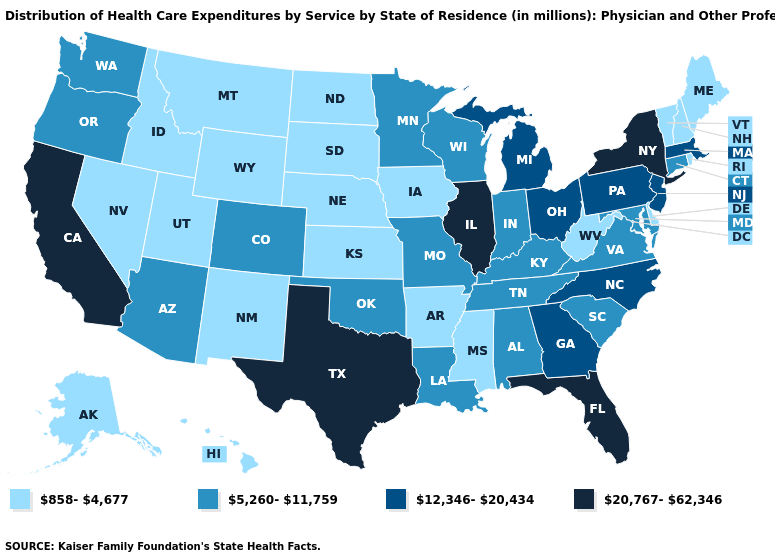How many symbols are there in the legend?
Concise answer only. 4. What is the highest value in the USA?
Give a very brief answer. 20,767-62,346. Name the states that have a value in the range 20,767-62,346?
Keep it brief. California, Florida, Illinois, New York, Texas. What is the lowest value in states that border California?
Write a very short answer. 858-4,677. Does Oregon have the same value as Rhode Island?
Give a very brief answer. No. What is the value of Massachusetts?
Give a very brief answer. 12,346-20,434. Name the states that have a value in the range 12,346-20,434?
Quick response, please. Georgia, Massachusetts, Michigan, New Jersey, North Carolina, Ohio, Pennsylvania. Name the states that have a value in the range 858-4,677?
Quick response, please. Alaska, Arkansas, Delaware, Hawaii, Idaho, Iowa, Kansas, Maine, Mississippi, Montana, Nebraska, Nevada, New Hampshire, New Mexico, North Dakota, Rhode Island, South Dakota, Utah, Vermont, West Virginia, Wyoming. Does the map have missing data?
Give a very brief answer. No. Does the map have missing data?
Short answer required. No. Is the legend a continuous bar?
Quick response, please. No. Which states hav the highest value in the MidWest?
Concise answer only. Illinois. What is the highest value in states that border New Hampshire?
Answer briefly. 12,346-20,434. Name the states that have a value in the range 858-4,677?
Give a very brief answer. Alaska, Arkansas, Delaware, Hawaii, Idaho, Iowa, Kansas, Maine, Mississippi, Montana, Nebraska, Nevada, New Hampshire, New Mexico, North Dakota, Rhode Island, South Dakota, Utah, Vermont, West Virginia, Wyoming. 